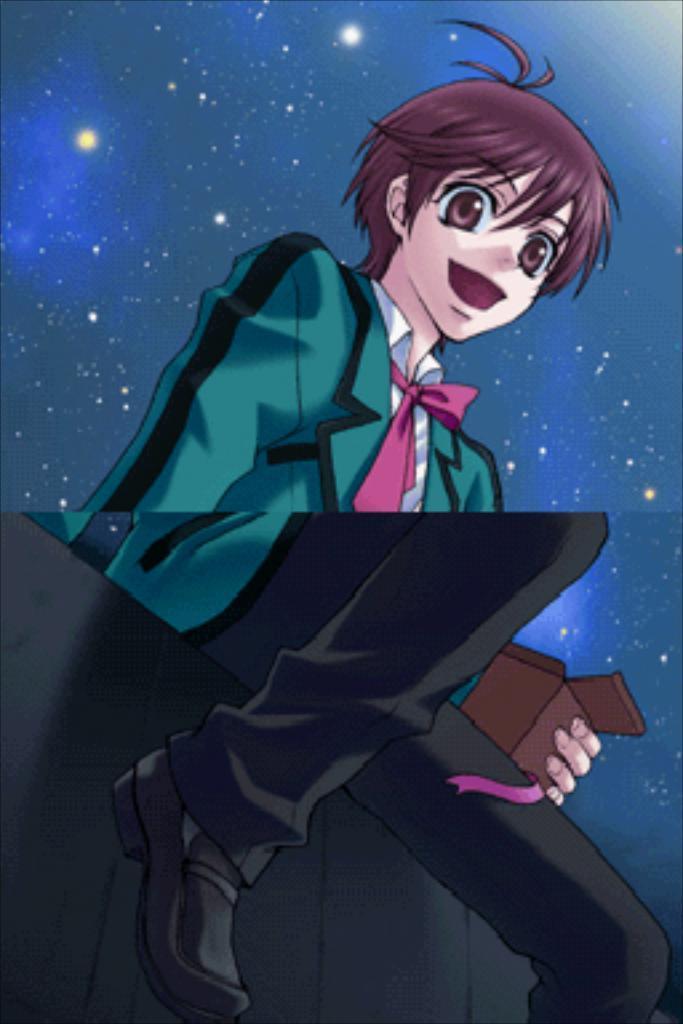Please provide a concise description of this image. In the picture I can see a cartoon image of a person who is sitting on something and holding an object in the hand. In the background I can see stars. 